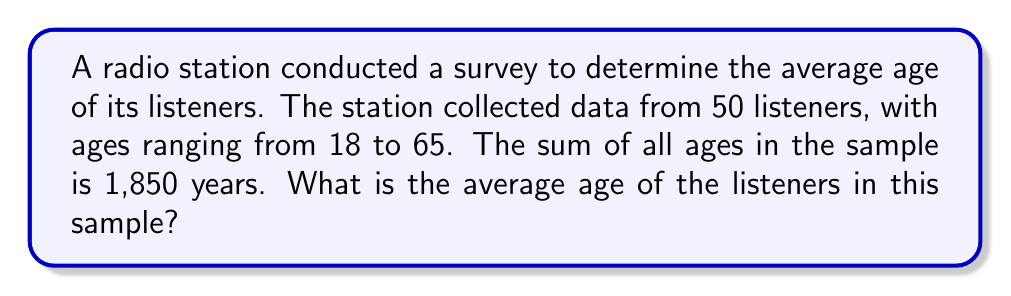Teach me how to tackle this problem. To find the average age of the listeners, we need to use the formula for calculating the arithmetic mean:

$$ \text{Average} = \frac{\text{Sum of all values}}{\text{Number of values}} $$

Given:
- Number of listeners surveyed: 50
- Sum of all ages: 1,850 years

Let's plug these values into the formula:

$$ \text{Average age} = \frac{1,850}{50} $$

Now, let's perform the division:

$$ \text{Average age} = 37 $$

Therefore, the average age of the listeners in this sample is 37 years old.

This information is crucial for the radio executive to understand their current audience demographics and make informed decisions about potentially adjusting their playlist to maintain or shift their target audience age range.
Answer: 37 years 